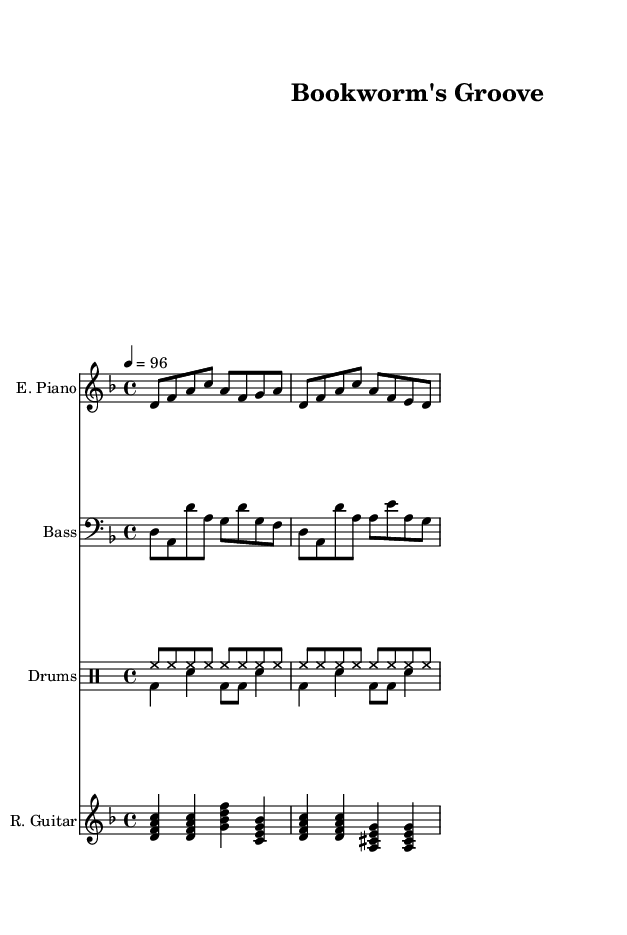What is the key signature of this music? The key signature is D minor, indicated by one flat (B flat) on the staff.
Answer: D minor What is the time signature of the piece? The time signature is 4/4, visible in the beginning of the score where it shows the number of beats per measure.
Answer: 4/4 What is the tempo marking for this piece? The tempo marking is 4 = 96, which indicates a pace of 96 beats per minute, signifying a moderate tempo.
Answer: 96 How many measures are in the score for the electric piano? The electric piano part consists of 4 measures, as counted by the notation and the bar lines present.
Answer: 4 What type of instrument is used for the rhythm guitar part? The rhythm guitar part is played by a standard guitar, indicated by "R. Guitar" in the score.
Answer: Rhythm guitar Which instruments are included in the arrangement? The arrangement includes electric piano, bass, drums, and rhythm guitar, as listed at the beginning of each staff.
Answer: Electric piano, bass, drums, rhythm guitar What is the primary feel of the rhythm section based on the drum patterns? The primary feel is upbeat and consistent, characterized by the continuous hi-hat and varied bass drum patterns typical in funk music.
Answer: Upbeat and consistent 